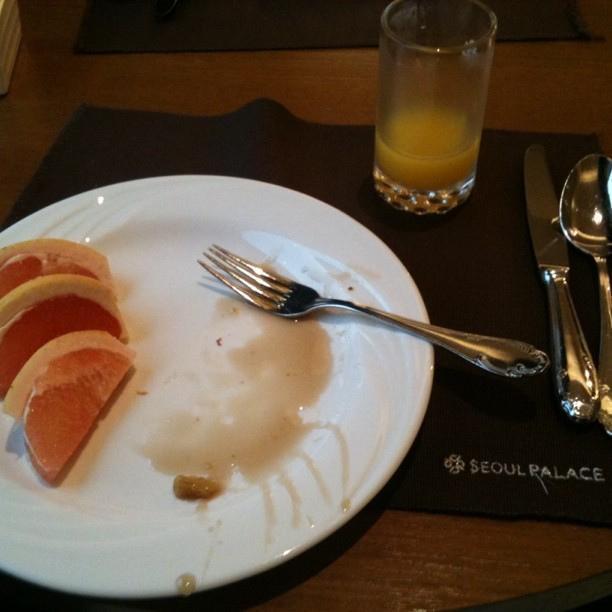How many forks are there?
Give a very brief answer. 1. How many utensils are visible?
Give a very brief answer. 3. How many holes are in the spoon?
Give a very brief answer. 0. How many desserts are on the table?
Give a very brief answer. 1. How many knives can you see?
Give a very brief answer. 1. How many oranges can you see?
Give a very brief answer. 2. 